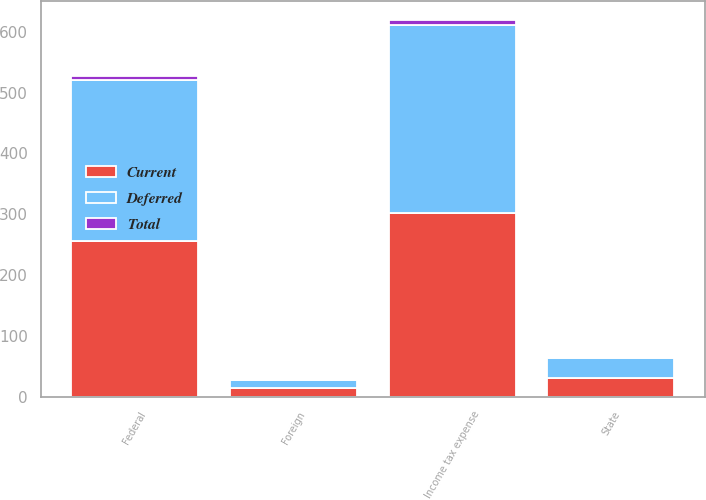<chart> <loc_0><loc_0><loc_500><loc_500><stacked_bar_chart><ecel><fcel>Federal<fcel>State<fcel>Foreign<fcel>Income tax expense<nl><fcel>Current<fcel>256.7<fcel>31.3<fcel>13.7<fcel>301.7<nl><fcel>Total<fcel>7.4<fcel>0.2<fcel>0.4<fcel>8<nl><fcel>Deferred<fcel>264.1<fcel>31.5<fcel>14.1<fcel>309.7<nl></chart> 